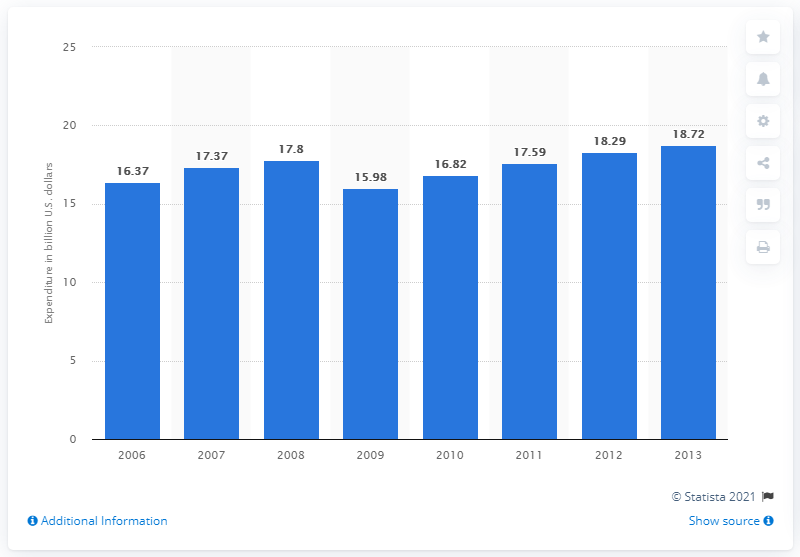Identify some key points in this picture. In 2013, the North American cruise industry spent approximately 18.72 million dollars in the United States. 